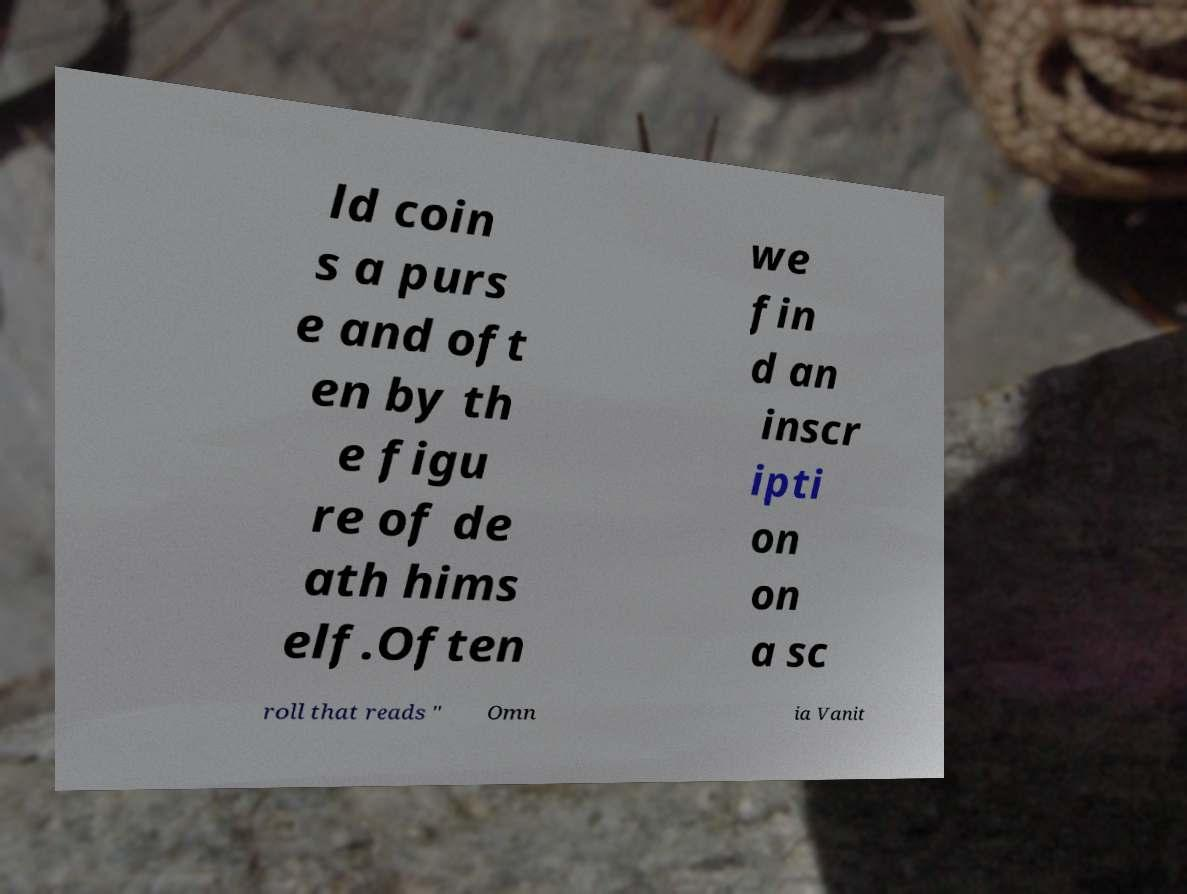Could you assist in decoding the text presented in this image and type it out clearly? ld coin s a purs e and oft en by th e figu re of de ath hims elf.Often we fin d an inscr ipti on on a sc roll that reads " Omn ia Vanit 